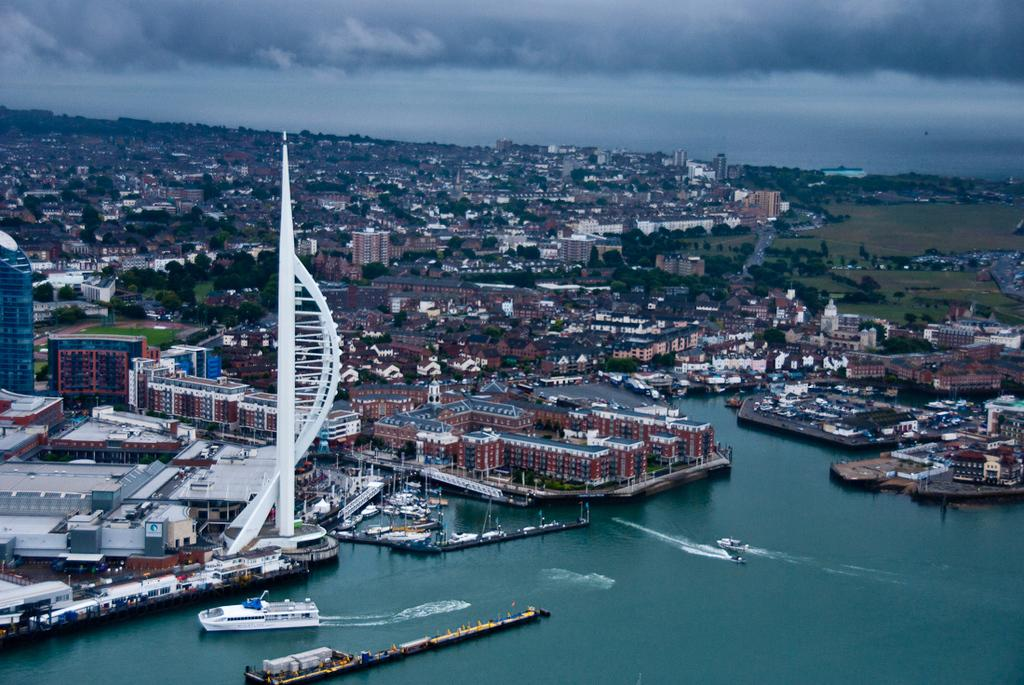What is on the water in the image? There are boats on the water in the image. What else can be seen in the image besides the boats? There are buildings visible in the image, as well as trees. What is visible in the background of the image? The sky is visible in the background of the image. What can be observed in the sky? Clouds are present in the sky. What type of bait is being used by the man in the image? There is no man present in the image, and therefore no bait or fishing activity can be observed. 